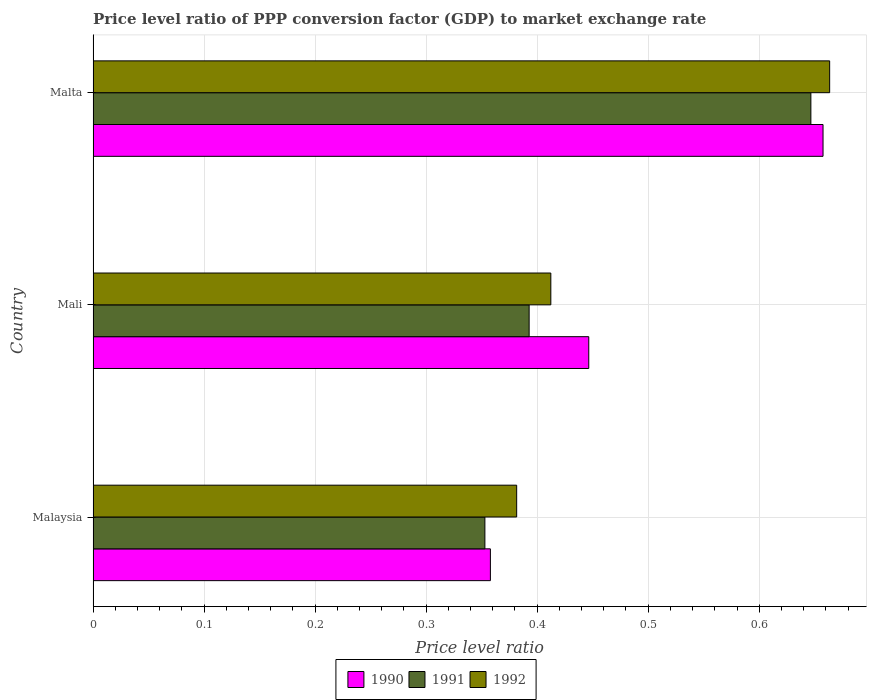How many groups of bars are there?
Ensure brevity in your answer.  3. Are the number of bars on each tick of the Y-axis equal?
Offer a terse response. Yes. What is the label of the 2nd group of bars from the top?
Provide a succinct answer. Mali. What is the price level ratio in 1992 in Malaysia?
Keep it short and to the point. 0.38. Across all countries, what is the maximum price level ratio in 1990?
Your answer should be compact. 0.66. Across all countries, what is the minimum price level ratio in 1992?
Your answer should be compact. 0.38. In which country was the price level ratio in 1992 maximum?
Ensure brevity in your answer.  Malta. In which country was the price level ratio in 1992 minimum?
Your answer should be compact. Malaysia. What is the total price level ratio in 1990 in the graph?
Make the answer very short. 1.46. What is the difference between the price level ratio in 1990 in Malaysia and that in Mali?
Keep it short and to the point. -0.09. What is the difference between the price level ratio in 1992 in Malta and the price level ratio in 1990 in Mali?
Ensure brevity in your answer.  0.22. What is the average price level ratio in 1992 per country?
Ensure brevity in your answer.  0.49. What is the difference between the price level ratio in 1991 and price level ratio in 1992 in Malta?
Give a very brief answer. -0.02. What is the ratio of the price level ratio in 1991 in Malaysia to that in Mali?
Provide a short and direct response. 0.9. Is the price level ratio in 1991 in Malaysia less than that in Malta?
Make the answer very short. Yes. What is the difference between the highest and the second highest price level ratio in 1992?
Make the answer very short. 0.25. What is the difference between the highest and the lowest price level ratio in 1992?
Give a very brief answer. 0.28. What does the 2nd bar from the top in Malaysia represents?
Keep it short and to the point. 1991. What does the 2nd bar from the bottom in Mali represents?
Make the answer very short. 1991. Is it the case that in every country, the sum of the price level ratio in 1990 and price level ratio in 1991 is greater than the price level ratio in 1992?
Your answer should be very brief. Yes. How many bars are there?
Give a very brief answer. 9. Are all the bars in the graph horizontal?
Offer a very short reply. Yes. How many countries are there in the graph?
Keep it short and to the point. 3. What is the difference between two consecutive major ticks on the X-axis?
Provide a short and direct response. 0.1. Does the graph contain grids?
Offer a terse response. Yes. How are the legend labels stacked?
Your answer should be compact. Horizontal. What is the title of the graph?
Your answer should be compact. Price level ratio of PPP conversion factor (GDP) to market exchange rate. What is the label or title of the X-axis?
Your answer should be compact. Price level ratio. What is the Price level ratio of 1990 in Malaysia?
Keep it short and to the point. 0.36. What is the Price level ratio in 1991 in Malaysia?
Your answer should be compact. 0.35. What is the Price level ratio in 1992 in Malaysia?
Make the answer very short. 0.38. What is the Price level ratio in 1990 in Mali?
Your answer should be compact. 0.45. What is the Price level ratio in 1991 in Mali?
Give a very brief answer. 0.39. What is the Price level ratio of 1992 in Mali?
Provide a short and direct response. 0.41. What is the Price level ratio in 1990 in Malta?
Offer a terse response. 0.66. What is the Price level ratio of 1991 in Malta?
Make the answer very short. 0.65. What is the Price level ratio in 1992 in Malta?
Ensure brevity in your answer.  0.66. Across all countries, what is the maximum Price level ratio in 1990?
Your response must be concise. 0.66. Across all countries, what is the maximum Price level ratio in 1991?
Provide a succinct answer. 0.65. Across all countries, what is the maximum Price level ratio of 1992?
Give a very brief answer. 0.66. Across all countries, what is the minimum Price level ratio of 1990?
Ensure brevity in your answer.  0.36. Across all countries, what is the minimum Price level ratio in 1991?
Keep it short and to the point. 0.35. Across all countries, what is the minimum Price level ratio in 1992?
Provide a short and direct response. 0.38. What is the total Price level ratio of 1990 in the graph?
Offer a very short reply. 1.46. What is the total Price level ratio of 1991 in the graph?
Keep it short and to the point. 1.39. What is the total Price level ratio in 1992 in the graph?
Provide a succinct answer. 1.46. What is the difference between the Price level ratio of 1990 in Malaysia and that in Mali?
Give a very brief answer. -0.09. What is the difference between the Price level ratio in 1991 in Malaysia and that in Mali?
Your answer should be very brief. -0.04. What is the difference between the Price level ratio in 1992 in Malaysia and that in Mali?
Your answer should be very brief. -0.03. What is the difference between the Price level ratio of 1990 in Malaysia and that in Malta?
Your answer should be very brief. -0.3. What is the difference between the Price level ratio in 1991 in Malaysia and that in Malta?
Your answer should be very brief. -0.29. What is the difference between the Price level ratio in 1992 in Malaysia and that in Malta?
Your answer should be compact. -0.28. What is the difference between the Price level ratio in 1990 in Mali and that in Malta?
Provide a short and direct response. -0.21. What is the difference between the Price level ratio of 1991 in Mali and that in Malta?
Provide a succinct answer. -0.25. What is the difference between the Price level ratio in 1992 in Mali and that in Malta?
Offer a terse response. -0.25. What is the difference between the Price level ratio in 1990 in Malaysia and the Price level ratio in 1991 in Mali?
Ensure brevity in your answer.  -0.03. What is the difference between the Price level ratio of 1990 in Malaysia and the Price level ratio of 1992 in Mali?
Your answer should be compact. -0.05. What is the difference between the Price level ratio in 1991 in Malaysia and the Price level ratio in 1992 in Mali?
Make the answer very short. -0.06. What is the difference between the Price level ratio of 1990 in Malaysia and the Price level ratio of 1991 in Malta?
Provide a succinct answer. -0.29. What is the difference between the Price level ratio in 1990 in Malaysia and the Price level ratio in 1992 in Malta?
Provide a succinct answer. -0.31. What is the difference between the Price level ratio of 1991 in Malaysia and the Price level ratio of 1992 in Malta?
Ensure brevity in your answer.  -0.31. What is the difference between the Price level ratio of 1990 in Mali and the Price level ratio of 1991 in Malta?
Give a very brief answer. -0.2. What is the difference between the Price level ratio in 1990 in Mali and the Price level ratio in 1992 in Malta?
Your answer should be very brief. -0.22. What is the difference between the Price level ratio of 1991 in Mali and the Price level ratio of 1992 in Malta?
Make the answer very short. -0.27. What is the average Price level ratio of 1990 per country?
Your response must be concise. 0.49. What is the average Price level ratio in 1991 per country?
Provide a short and direct response. 0.46. What is the average Price level ratio in 1992 per country?
Your response must be concise. 0.49. What is the difference between the Price level ratio of 1990 and Price level ratio of 1991 in Malaysia?
Your answer should be very brief. 0. What is the difference between the Price level ratio of 1990 and Price level ratio of 1992 in Malaysia?
Your answer should be very brief. -0.02. What is the difference between the Price level ratio in 1991 and Price level ratio in 1992 in Malaysia?
Ensure brevity in your answer.  -0.03. What is the difference between the Price level ratio in 1990 and Price level ratio in 1991 in Mali?
Provide a succinct answer. 0.05. What is the difference between the Price level ratio of 1990 and Price level ratio of 1992 in Mali?
Your answer should be very brief. 0.03. What is the difference between the Price level ratio of 1991 and Price level ratio of 1992 in Mali?
Your response must be concise. -0.02. What is the difference between the Price level ratio of 1990 and Price level ratio of 1991 in Malta?
Provide a succinct answer. 0.01. What is the difference between the Price level ratio of 1990 and Price level ratio of 1992 in Malta?
Your answer should be very brief. -0.01. What is the difference between the Price level ratio of 1991 and Price level ratio of 1992 in Malta?
Your answer should be compact. -0.02. What is the ratio of the Price level ratio of 1990 in Malaysia to that in Mali?
Your response must be concise. 0.8. What is the ratio of the Price level ratio of 1991 in Malaysia to that in Mali?
Your answer should be very brief. 0.9. What is the ratio of the Price level ratio of 1992 in Malaysia to that in Mali?
Give a very brief answer. 0.93. What is the ratio of the Price level ratio of 1990 in Malaysia to that in Malta?
Your answer should be very brief. 0.54. What is the ratio of the Price level ratio in 1991 in Malaysia to that in Malta?
Provide a succinct answer. 0.55. What is the ratio of the Price level ratio of 1992 in Malaysia to that in Malta?
Provide a short and direct response. 0.58. What is the ratio of the Price level ratio of 1990 in Mali to that in Malta?
Your answer should be very brief. 0.68. What is the ratio of the Price level ratio in 1991 in Mali to that in Malta?
Offer a very short reply. 0.61. What is the ratio of the Price level ratio of 1992 in Mali to that in Malta?
Offer a terse response. 0.62. What is the difference between the highest and the second highest Price level ratio in 1990?
Keep it short and to the point. 0.21. What is the difference between the highest and the second highest Price level ratio of 1991?
Your answer should be compact. 0.25. What is the difference between the highest and the second highest Price level ratio of 1992?
Provide a short and direct response. 0.25. What is the difference between the highest and the lowest Price level ratio in 1990?
Your answer should be very brief. 0.3. What is the difference between the highest and the lowest Price level ratio in 1991?
Give a very brief answer. 0.29. What is the difference between the highest and the lowest Price level ratio of 1992?
Provide a succinct answer. 0.28. 